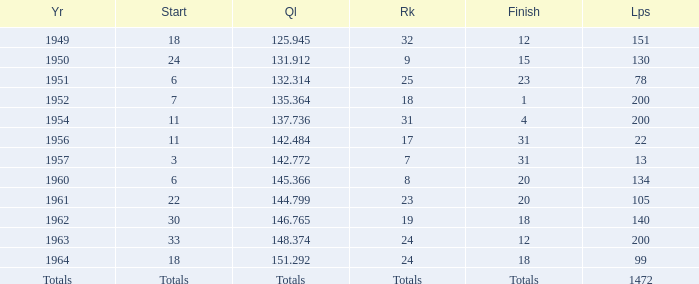Name the rank with finish of 12 and year of 1963 24.0. 